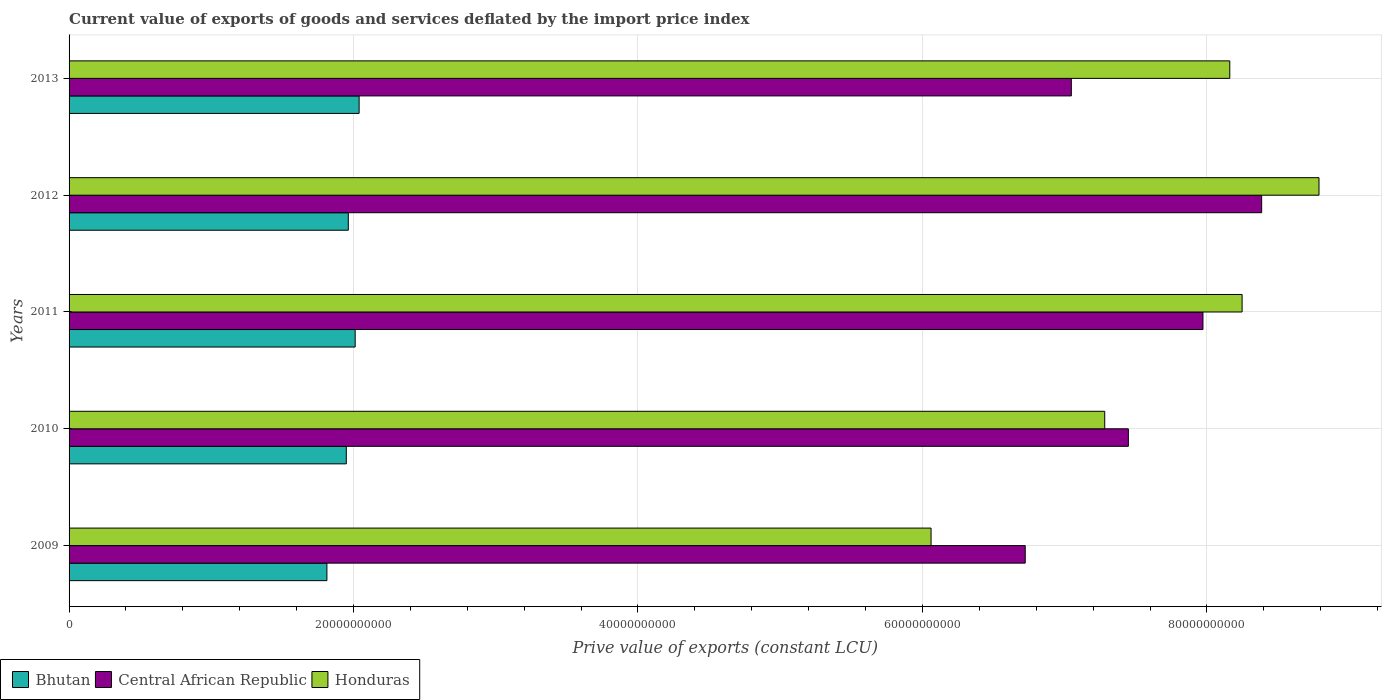How many bars are there on the 4th tick from the bottom?
Keep it short and to the point. 3. What is the prive value of exports in Honduras in 2012?
Your answer should be very brief. 8.79e+1. Across all years, what is the maximum prive value of exports in Bhutan?
Provide a succinct answer. 2.04e+1. Across all years, what is the minimum prive value of exports in Honduras?
Provide a short and direct response. 6.06e+1. What is the total prive value of exports in Central African Republic in the graph?
Your answer should be very brief. 3.76e+11. What is the difference between the prive value of exports in Bhutan in 2009 and that in 2011?
Offer a very short reply. -1.99e+09. What is the difference between the prive value of exports in Honduras in 2013 and the prive value of exports in Bhutan in 2012?
Your answer should be very brief. 6.20e+1. What is the average prive value of exports in Bhutan per year?
Offer a very short reply. 1.96e+1. In the year 2012, what is the difference between the prive value of exports in Central African Republic and prive value of exports in Bhutan?
Offer a very short reply. 6.42e+1. What is the ratio of the prive value of exports in Bhutan in 2009 to that in 2011?
Your response must be concise. 0.9. Is the prive value of exports in Central African Republic in 2010 less than that in 2011?
Keep it short and to the point. Yes. Is the difference between the prive value of exports in Central African Republic in 2012 and 2013 greater than the difference between the prive value of exports in Bhutan in 2012 and 2013?
Offer a very short reply. Yes. What is the difference between the highest and the second highest prive value of exports in Central African Republic?
Your response must be concise. 4.13e+09. What is the difference between the highest and the lowest prive value of exports in Central African Republic?
Keep it short and to the point. 1.66e+1. What does the 3rd bar from the top in 2013 represents?
Give a very brief answer. Bhutan. What does the 3rd bar from the bottom in 2012 represents?
Your response must be concise. Honduras. How many bars are there?
Provide a short and direct response. 15. Are all the bars in the graph horizontal?
Keep it short and to the point. Yes. How many years are there in the graph?
Your answer should be very brief. 5. Are the values on the major ticks of X-axis written in scientific E-notation?
Provide a succinct answer. No. Does the graph contain any zero values?
Provide a short and direct response. No. How many legend labels are there?
Provide a succinct answer. 3. What is the title of the graph?
Provide a short and direct response. Current value of exports of goods and services deflated by the import price index. Does "South Africa" appear as one of the legend labels in the graph?
Your response must be concise. No. What is the label or title of the X-axis?
Your answer should be very brief. Prive value of exports (constant LCU). What is the Prive value of exports (constant LCU) in Bhutan in 2009?
Give a very brief answer. 1.81e+1. What is the Prive value of exports (constant LCU) of Central African Republic in 2009?
Your response must be concise. 6.72e+1. What is the Prive value of exports (constant LCU) in Honduras in 2009?
Keep it short and to the point. 6.06e+1. What is the Prive value of exports (constant LCU) in Bhutan in 2010?
Offer a terse response. 1.95e+1. What is the Prive value of exports (constant LCU) of Central African Republic in 2010?
Provide a short and direct response. 7.45e+1. What is the Prive value of exports (constant LCU) of Honduras in 2010?
Give a very brief answer. 7.28e+1. What is the Prive value of exports (constant LCU) in Bhutan in 2011?
Offer a terse response. 2.01e+1. What is the Prive value of exports (constant LCU) in Central African Republic in 2011?
Offer a very short reply. 7.97e+1. What is the Prive value of exports (constant LCU) of Honduras in 2011?
Your answer should be compact. 8.25e+1. What is the Prive value of exports (constant LCU) in Bhutan in 2012?
Provide a short and direct response. 1.96e+1. What is the Prive value of exports (constant LCU) in Central African Republic in 2012?
Give a very brief answer. 8.39e+1. What is the Prive value of exports (constant LCU) in Honduras in 2012?
Your answer should be very brief. 8.79e+1. What is the Prive value of exports (constant LCU) in Bhutan in 2013?
Give a very brief answer. 2.04e+1. What is the Prive value of exports (constant LCU) of Central African Republic in 2013?
Offer a very short reply. 7.05e+1. What is the Prive value of exports (constant LCU) in Honduras in 2013?
Your response must be concise. 8.16e+1. Across all years, what is the maximum Prive value of exports (constant LCU) of Bhutan?
Your answer should be very brief. 2.04e+1. Across all years, what is the maximum Prive value of exports (constant LCU) in Central African Republic?
Offer a terse response. 8.39e+1. Across all years, what is the maximum Prive value of exports (constant LCU) of Honduras?
Your answer should be very brief. 8.79e+1. Across all years, what is the minimum Prive value of exports (constant LCU) of Bhutan?
Your answer should be very brief. 1.81e+1. Across all years, what is the minimum Prive value of exports (constant LCU) of Central African Republic?
Offer a terse response. 6.72e+1. Across all years, what is the minimum Prive value of exports (constant LCU) in Honduras?
Make the answer very short. 6.06e+1. What is the total Prive value of exports (constant LCU) of Bhutan in the graph?
Keep it short and to the point. 9.78e+1. What is the total Prive value of exports (constant LCU) in Central African Republic in the graph?
Keep it short and to the point. 3.76e+11. What is the total Prive value of exports (constant LCU) in Honduras in the graph?
Provide a short and direct response. 3.85e+11. What is the difference between the Prive value of exports (constant LCU) in Bhutan in 2009 and that in 2010?
Offer a terse response. -1.36e+09. What is the difference between the Prive value of exports (constant LCU) of Central African Republic in 2009 and that in 2010?
Give a very brief answer. -7.25e+09. What is the difference between the Prive value of exports (constant LCU) in Honduras in 2009 and that in 2010?
Provide a succinct answer. -1.22e+1. What is the difference between the Prive value of exports (constant LCU) of Bhutan in 2009 and that in 2011?
Your response must be concise. -1.99e+09. What is the difference between the Prive value of exports (constant LCU) in Central African Republic in 2009 and that in 2011?
Your response must be concise. -1.25e+1. What is the difference between the Prive value of exports (constant LCU) of Honduras in 2009 and that in 2011?
Ensure brevity in your answer.  -2.19e+1. What is the difference between the Prive value of exports (constant LCU) in Bhutan in 2009 and that in 2012?
Your answer should be compact. -1.50e+09. What is the difference between the Prive value of exports (constant LCU) of Central African Republic in 2009 and that in 2012?
Provide a succinct answer. -1.66e+1. What is the difference between the Prive value of exports (constant LCU) of Honduras in 2009 and that in 2012?
Keep it short and to the point. -2.73e+1. What is the difference between the Prive value of exports (constant LCU) of Bhutan in 2009 and that in 2013?
Offer a terse response. -2.26e+09. What is the difference between the Prive value of exports (constant LCU) in Central African Republic in 2009 and that in 2013?
Your answer should be very brief. -3.24e+09. What is the difference between the Prive value of exports (constant LCU) in Honduras in 2009 and that in 2013?
Keep it short and to the point. -2.10e+1. What is the difference between the Prive value of exports (constant LCU) of Bhutan in 2010 and that in 2011?
Offer a terse response. -6.25e+08. What is the difference between the Prive value of exports (constant LCU) of Central African Republic in 2010 and that in 2011?
Your answer should be compact. -5.24e+09. What is the difference between the Prive value of exports (constant LCU) of Honduras in 2010 and that in 2011?
Keep it short and to the point. -9.66e+09. What is the difference between the Prive value of exports (constant LCU) in Bhutan in 2010 and that in 2012?
Offer a very short reply. -1.41e+08. What is the difference between the Prive value of exports (constant LCU) in Central African Republic in 2010 and that in 2012?
Give a very brief answer. -9.37e+09. What is the difference between the Prive value of exports (constant LCU) in Honduras in 2010 and that in 2012?
Your response must be concise. -1.51e+1. What is the difference between the Prive value of exports (constant LCU) of Bhutan in 2010 and that in 2013?
Your response must be concise. -9.02e+08. What is the difference between the Prive value of exports (constant LCU) of Central African Republic in 2010 and that in 2013?
Your answer should be very brief. 4.01e+09. What is the difference between the Prive value of exports (constant LCU) of Honduras in 2010 and that in 2013?
Your answer should be very brief. -8.79e+09. What is the difference between the Prive value of exports (constant LCU) of Bhutan in 2011 and that in 2012?
Offer a very short reply. 4.83e+08. What is the difference between the Prive value of exports (constant LCU) in Central African Republic in 2011 and that in 2012?
Make the answer very short. -4.13e+09. What is the difference between the Prive value of exports (constant LCU) of Honduras in 2011 and that in 2012?
Your response must be concise. -5.41e+09. What is the difference between the Prive value of exports (constant LCU) in Bhutan in 2011 and that in 2013?
Ensure brevity in your answer.  -2.77e+08. What is the difference between the Prive value of exports (constant LCU) in Central African Republic in 2011 and that in 2013?
Give a very brief answer. 9.25e+09. What is the difference between the Prive value of exports (constant LCU) of Honduras in 2011 and that in 2013?
Make the answer very short. 8.67e+08. What is the difference between the Prive value of exports (constant LCU) of Bhutan in 2012 and that in 2013?
Give a very brief answer. -7.60e+08. What is the difference between the Prive value of exports (constant LCU) of Central African Republic in 2012 and that in 2013?
Your answer should be compact. 1.34e+1. What is the difference between the Prive value of exports (constant LCU) of Honduras in 2012 and that in 2013?
Provide a short and direct response. 6.27e+09. What is the difference between the Prive value of exports (constant LCU) in Bhutan in 2009 and the Prive value of exports (constant LCU) in Central African Republic in 2010?
Ensure brevity in your answer.  -5.64e+1. What is the difference between the Prive value of exports (constant LCU) of Bhutan in 2009 and the Prive value of exports (constant LCU) of Honduras in 2010?
Your answer should be very brief. -5.47e+1. What is the difference between the Prive value of exports (constant LCU) of Central African Republic in 2009 and the Prive value of exports (constant LCU) of Honduras in 2010?
Your answer should be very brief. -5.59e+09. What is the difference between the Prive value of exports (constant LCU) in Bhutan in 2009 and the Prive value of exports (constant LCU) in Central African Republic in 2011?
Make the answer very short. -6.16e+1. What is the difference between the Prive value of exports (constant LCU) in Bhutan in 2009 and the Prive value of exports (constant LCU) in Honduras in 2011?
Your response must be concise. -6.43e+1. What is the difference between the Prive value of exports (constant LCU) of Central African Republic in 2009 and the Prive value of exports (constant LCU) of Honduras in 2011?
Offer a very short reply. -1.52e+1. What is the difference between the Prive value of exports (constant LCU) in Bhutan in 2009 and the Prive value of exports (constant LCU) in Central African Republic in 2012?
Ensure brevity in your answer.  -6.57e+1. What is the difference between the Prive value of exports (constant LCU) in Bhutan in 2009 and the Prive value of exports (constant LCU) in Honduras in 2012?
Your answer should be compact. -6.98e+1. What is the difference between the Prive value of exports (constant LCU) of Central African Republic in 2009 and the Prive value of exports (constant LCU) of Honduras in 2012?
Offer a terse response. -2.07e+1. What is the difference between the Prive value of exports (constant LCU) of Bhutan in 2009 and the Prive value of exports (constant LCU) of Central African Republic in 2013?
Offer a very short reply. -5.23e+1. What is the difference between the Prive value of exports (constant LCU) of Bhutan in 2009 and the Prive value of exports (constant LCU) of Honduras in 2013?
Your answer should be compact. -6.35e+1. What is the difference between the Prive value of exports (constant LCU) of Central African Republic in 2009 and the Prive value of exports (constant LCU) of Honduras in 2013?
Make the answer very short. -1.44e+1. What is the difference between the Prive value of exports (constant LCU) of Bhutan in 2010 and the Prive value of exports (constant LCU) of Central African Republic in 2011?
Your response must be concise. -6.02e+1. What is the difference between the Prive value of exports (constant LCU) of Bhutan in 2010 and the Prive value of exports (constant LCU) of Honduras in 2011?
Offer a very short reply. -6.30e+1. What is the difference between the Prive value of exports (constant LCU) of Central African Republic in 2010 and the Prive value of exports (constant LCU) of Honduras in 2011?
Your answer should be compact. -8.00e+09. What is the difference between the Prive value of exports (constant LCU) in Bhutan in 2010 and the Prive value of exports (constant LCU) in Central African Republic in 2012?
Make the answer very short. -6.44e+1. What is the difference between the Prive value of exports (constant LCU) of Bhutan in 2010 and the Prive value of exports (constant LCU) of Honduras in 2012?
Keep it short and to the point. -6.84e+1. What is the difference between the Prive value of exports (constant LCU) in Central African Republic in 2010 and the Prive value of exports (constant LCU) in Honduras in 2012?
Offer a terse response. -1.34e+1. What is the difference between the Prive value of exports (constant LCU) of Bhutan in 2010 and the Prive value of exports (constant LCU) of Central African Republic in 2013?
Your answer should be compact. -5.10e+1. What is the difference between the Prive value of exports (constant LCU) of Bhutan in 2010 and the Prive value of exports (constant LCU) of Honduras in 2013?
Ensure brevity in your answer.  -6.21e+1. What is the difference between the Prive value of exports (constant LCU) in Central African Republic in 2010 and the Prive value of exports (constant LCU) in Honduras in 2013?
Make the answer very short. -7.13e+09. What is the difference between the Prive value of exports (constant LCU) in Bhutan in 2011 and the Prive value of exports (constant LCU) in Central African Republic in 2012?
Offer a very short reply. -6.37e+1. What is the difference between the Prive value of exports (constant LCU) of Bhutan in 2011 and the Prive value of exports (constant LCU) of Honduras in 2012?
Provide a succinct answer. -6.78e+1. What is the difference between the Prive value of exports (constant LCU) of Central African Republic in 2011 and the Prive value of exports (constant LCU) of Honduras in 2012?
Your answer should be very brief. -8.16e+09. What is the difference between the Prive value of exports (constant LCU) of Bhutan in 2011 and the Prive value of exports (constant LCU) of Central African Republic in 2013?
Give a very brief answer. -5.04e+1. What is the difference between the Prive value of exports (constant LCU) of Bhutan in 2011 and the Prive value of exports (constant LCU) of Honduras in 2013?
Offer a very short reply. -6.15e+1. What is the difference between the Prive value of exports (constant LCU) of Central African Republic in 2011 and the Prive value of exports (constant LCU) of Honduras in 2013?
Make the answer very short. -1.89e+09. What is the difference between the Prive value of exports (constant LCU) of Bhutan in 2012 and the Prive value of exports (constant LCU) of Central African Republic in 2013?
Keep it short and to the point. -5.08e+1. What is the difference between the Prive value of exports (constant LCU) of Bhutan in 2012 and the Prive value of exports (constant LCU) of Honduras in 2013?
Provide a short and direct response. -6.20e+1. What is the difference between the Prive value of exports (constant LCU) in Central African Republic in 2012 and the Prive value of exports (constant LCU) in Honduras in 2013?
Ensure brevity in your answer.  2.24e+09. What is the average Prive value of exports (constant LCU) of Bhutan per year?
Your answer should be compact. 1.96e+1. What is the average Prive value of exports (constant LCU) of Central African Republic per year?
Your answer should be very brief. 7.51e+1. What is the average Prive value of exports (constant LCU) in Honduras per year?
Offer a terse response. 7.71e+1. In the year 2009, what is the difference between the Prive value of exports (constant LCU) in Bhutan and Prive value of exports (constant LCU) in Central African Republic?
Provide a short and direct response. -4.91e+1. In the year 2009, what is the difference between the Prive value of exports (constant LCU) in Bhutan and Prive value of exports (constant LCU) in Honduras?
Provide a short and direct response. -4.25e+1. In the year 2009, what is the difference between the Prive value of exports (constant LCU) in Central African Republic and Prive value of exports (constant LCU) in Honduras?
Ensure brevity in your answer.  6.62e+09. In the year 2010, what is the difference between the Prive value of exports (constant LCU) in Bhutan and Prive value of exports (constant LCU) in Central African Republic?
Offer a very short reply. -5.50e+1. In the year 2010, what is the difference between the Prive value of exports (constant LCU) of Bhutan and Prive value of exports (constant LCU) of Honduras?
Offer a very short reply. -5.33e+1. In the year 2010, what is the difference between the Prive value of exports (constant LCU) in Central African Republic and Prive value of exports (constant LCU) in Honduras?
Offer a very short reply. 1.66e+09. In the year 2011, what is the difference between the Prive value of exports (constant LCU) in Bhutan and Prive value of exports (constant LCU) in Central African Republic?
Provide a short and direct response. -5.96e+1. In the year 2011, what is the difference between the Prive value of exports (constant LCU) of Bhutan and Prive value of exports (constant LCU) of Honduras?
Provide a short and direct response. -6.24e+1. In the year 2011, what is the difference between the Prive value of exports (constant LCU) in Central African Republic and Prive value of exports (constant LCU) in Honduras?
Your answer should be compact. -2.75e+09. In the year 2012, what is the difference between the Prive value of exports (constant LCU) of Bhutan and Prive value of exports (constant LCU) of Central African Republic?
Give a very brief answer. -6.42e+1. In the year 2012, what is the difference between the Prive value of exports (constant LCU) in Bhutan and Prive value of exports (constant LCU) in Honduras?
Offer a very short reply. -6.82e+1. In the year 2012, what is the difference between the Prive value of exports (constant LCU) in Central African Republic and Prive value of exports (constant LCU) in Honduras?
Your response must be concise. -4.03e+09. In the year 2013, what is the difference between the Prive value of exports (constant LCU) of Bhutan and Prive value of exports (constant LCU) of Central African Republic?
Keep it short and to the point. -5.01e+1. In the year 2013, what is the difference between the Prive value of exports (constant LCU) in Bhutan and Prive value of exports (constant LCU) in Honduras?
Keep it short and to the point. -6.12e+1. In the year 2013, what is the difference between the Prive value of exports (constant LCU) in Central African Republic and Prive value of exports (constant LCU) in Honduras?
Provide a succinct answer. -1.11e+1. What is the ratio of the Prive value of exports (constant LCU) in Bhutan in 2009 to that in 2010?
Ensure brevity in your answer.  0.93. What is the ratio of the Prive value of exports (constant LCU) of Central African Republic in 2009 to that in 2010?
Your answer should be very brief. 0.9. What is the ratio of the Prive value of exports (constant LCU) of Honduras in 2009 to that in 2010?
Make the answer very short. 0.83. What is the ratio of the Prive value of exports (constant LCU) of Bhutan in 2009 to that in 2011?
Give a very brief answer. 0.9. What is the ratio of the Prive value of exports (constant LCU) in Central African Republic in 2009 to that in 2011?
Provide a succinct answer. 0.84. What is the ratio of the Prive value of exports (constant LCU) in Honduras in 2009 to that in 2011?
Keep it short and to the point. 0.73. What is the ratio of the Prive value of exports (constant LCU) of Bhutan in 2009 to that in 2012?
Your response must be concise. 0.92. What is the ratio of the Prive value of exports (constant LCU) of Central African Republic in 2009 to that in 2012?
Provide a short and direct response. 0.8. What is the ratio of the Prive value of exports (constant LCU) of Honduras in 2009 to that in 2012?
Make the answer very short. 0.69. What is the ratio of the Prive value of exports (constant LCU) in Central African Republic in 2009 to that in 2013?
Give a very brief answer. 0.95. What is the ratio of the Prive value of exports (constant LCU) in Honduras in 2009 to that in 2013?
Provide a short and direct response. 0.74. What is the ratio of the Prive value of exports (constant LCU) of Bhutan in 2010 to that in 2011?
Offer a very short reply. 0.97. What is the ratio of the Prive value of exports (constant LCU) in Central African Republic in 2010 to that in 2011?
Your answer should be very brief. 0.93. What is the ratio of the Prive value of exports (constant LCU) of Honduras in 2010 to that in 2011?
Offer a terse response. 0.88. What is the ratio of the Prive value of exports (constant LCU) in Central African Republic in 2010 to that in 2012?
Your response must be concise. 0.89. What is the ratio of the Prive value of exports (constant LCU) of Honduras in 2010 to that in 2012?
Your response must be concise. 0.83. What is the ratio of the Prive value of exports (constant LCU) of Bhutan in 2010 to that in 2013?
Your answer should be compact. 0.96. What is the ratio of the Prive value of exports (constant LCU) in Central African Republic in 2010 to that in 2013?
Ensure brevity in your answer.  1.06. What is the ratio of the Prive value of exports (constant LCU) of Honduras in 2010 to that in 2013?
Your response must be concise. 0.89. What is the ratio of the Prive value of exports (constant LCU) of Bhutan in 2011 to that in 2012?
Provide a succinct answer. 1.02. What is the ratio of the Prive value of exports (constant LCU) of Central African Republic in 2011 to that in 2012?
Ensure brevity in your answer.  0.95. What is the ratio of the Prive value of exports (constant LCU) of Honduras in 2011 to that in 2012?
Your answer should be compact. 0.94. What is the ratio of the Prive value of exports (constant LCU) of Bhutan in 2011 to that in 2013?
Make the answer very short. 0.99. What is the ratio of the Prive value of exports (constant LCU) of Central African Republic in 2011 to that in 2013?
Give a very brief answer. 1.13. What is the ratio of the Prive value of exports (constant LCU) in Honduras in 2011 to that in 2013?
Keep it short and to the point. 1.01. What is the ratio of the Prive value of exports (constant LCU) in Bhutan in 2012 to that in 2013?
Provide a short and direct response. 0.96. What is the ratio of the Prive value of exports (constant LCU) of Central African Republic in 2012 to that in 2013?
Ensure brevity in your answer.  1.19. What is the difference between the highest and the second highest Prive value of exports (constant LCU) in Bhutan?
Your answer should be compact. 2.77e+08. What is the difference between the highest and the second highest Prive value of exports (constant LCU) in Central African Republic?
Give a very brief answer. 4.13e+09. What is the difference between the highest and the second highest Prive value of exports (constant LCU) in Honduras?
Make the answer very short. 5.41e+09. What is the difference between the highest and the lowest Prive value of exports (constant LCU) of Bhutan?
Your answer should be very brief. 2.26e+09. What is the difference between the highest and the lowest Prive value of exports (constant LCU) in Central African Republic?
Provide a succinct answer. 1.66e+1. What is the difference between the highest and the lowest Prive value of exports (constant LCU) of Honduras?
Your answer should be compact. 2.73e+1. 